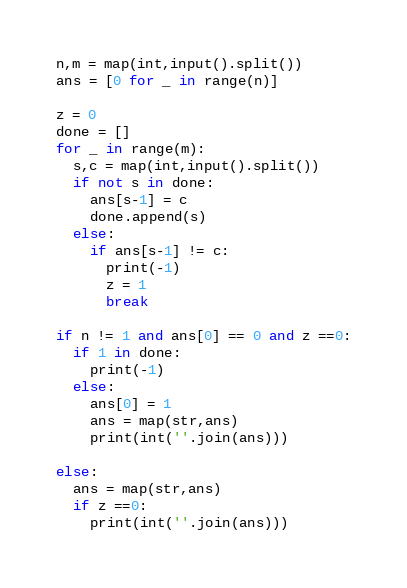Convert code to text. <code><loc_0><loc_0><loc_500><loc_500><_Python_>n,m = map(int,input().split())
ans = [0 for _ in range(n)]

z = 0
done = []
for _ in range(m):
  s,c = map(int,input().split())
  if not s in done:
    ans[s-1] = c
    done.append(s)
  else:
    if ans[s-1] != c:
      print(-1)
      z = 1
      break
      
if n != 1 and ans[0] == 0 and z ==0:
  if 1 in done:
  	print(-1)
  else:
    ans[0] = 1
    ans = map(str,ans)
    print(int(''.join(ans)))
    
else:
  ans = map(str,ans)
  if z ==0:
    print(int(''.join(ans)))</code> 